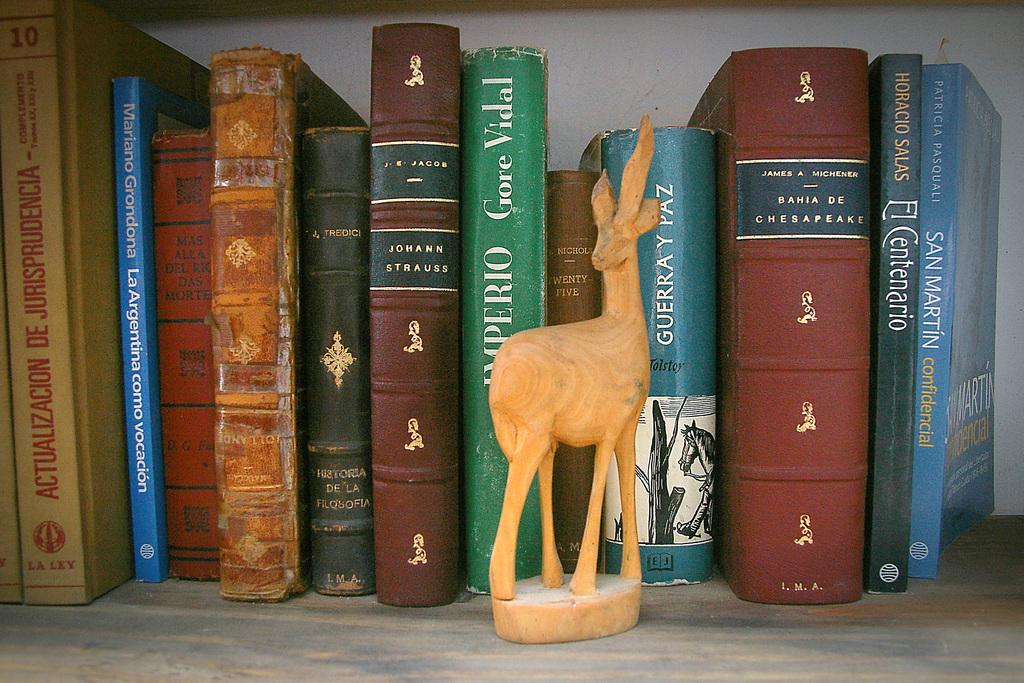What number is the tall yellow book on the left?
Your response must be concise. 10. What is title of the teal book?
Provide a short and direct response. Imperio. 